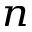Convert formula to latex. <formula><loc_0><loc_0><loc_500><loc_500>_ { n }</formula> 